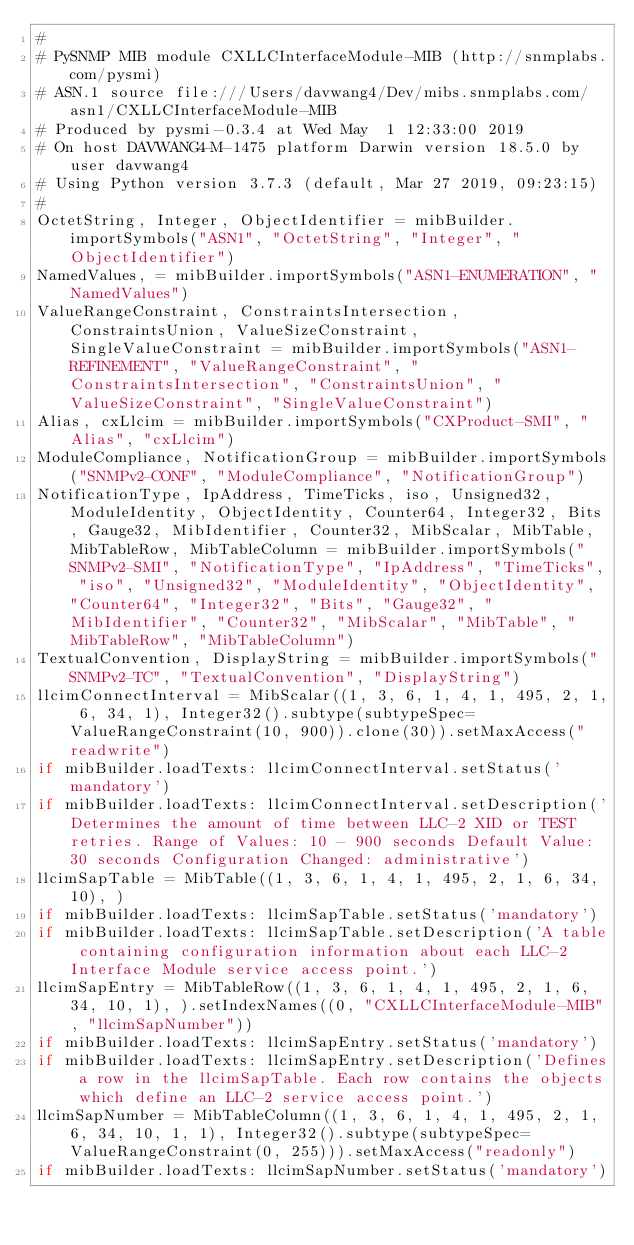Convert code to text. <code><loc_0><loc_0><loc_500><loc_500><_Python_>#
# PySNMP MIB module CXLLCInterfaceModule-MIB (http://snmplabs.com/pysmi)
# ASN.1 source file:///Users/davwang4/Dev/mibs.snmplabs.com/asn1/CXLLCInterfaceModule-MIB
# Produced by pysmi-0.3.4 at Wed May  1 12:33:00 2019
# On host DAVWANG4-M-1475 platform Darwin version 18.5.0 by user davwang4
# Using Python version 3.7.3 (default, Mar 27 2019, 09:23:15) 
#
OctetString, Integer, ObjectIdentifier = mibBuilder.importSymbols("ASN1", "OctetString", "Integer", "ObjectIdentifier")
NamedValues, = mibBuilder.importSymbols("ASN1-ENUMERATION", "NamedValues")
ValueRangeConstraint, ConstraintsIntersection, ConstraintsUnion, ValueSizeConstraint, SingleValueConstraint = mibBuilder.importSymbols("ASN1-REFINEMENT", "ValueRangeConstraint", "ConstraintsIntersection", "ConstraintsUnion", "ValueSizeConstraint", "SingleValueConstraint")
Alias, cxLlcim = mibBuilder.importSymbols("CXProduct-SMI", "Alias", "cxLlcim")
ModuleCompliance, NotificationGroup = mibBuilder.importSymbols("SNMPv2-CONF", "ModuleCompliance", "NotificationGroup")
NotificationType, IpAddress, TimeTicks, iso, Unsigned32, ModuleIdentity, ObjectIdentity, Counter64, Integer32, Bits, Gauge32, MibIdentifier, Counter32, MibScalar, MibTable, MibTableRow, MibTableColumn = mibBuilder.importSymbols("SNMPv2-SMI", "NotificationType", "IpAddress", "TimeTicks", "iso", "Unsigned32", "ModuleIdentity", "ObjectIdentity", "Counter64", "Integer32", "Bits", "Gauge32", "MibIdentifier", "Counter32", "MibScalar", "MibTable", "MibTableRow", "MibTableColumn")
TextualConvention, DisplayString = mibBuilder.importSymbols("SNMPv2-TC", "TextualConvention", "DisplayString")
llcimConnectInterval = MibScalar((1, 3, 6, 1, 4, 1, 495, 2, 1, 6, 34, 1), Integer32().subtype(subtypeSpec=ValueRangeConstraint(10, 900)).clone(30)).setMaxAccess("readwrite")
if mibBuilder.loadTexts: llcimConnectInterval.setStatus('mandatory')
if mibBuilder.loadTexts: llcimConnectInterval.setDescription('Determines the amount of time between LLC-2 XID or TEST retries. Range of Values: 10 - 900 seconds Default Value: 30 seconds Configuration Changed: administrative')
llcimSapTable = MibTable((1, 3, 6, 1, 4, 1, 495, 2, 1, 6, 34, 10), )
if mibBuilder.loadTexts: llcimSapTable.setStatus('mandatory')
if mibBuilder.loadTexts: llcimSapTable.setDescription('A table containing configuration information about each LLC-2 Interface Module service access point.')
llcimSapEntry = MibTableRow((1, 3, 6, 1, 4, 1, 495, 2, 1, 6, 34, 10, 1), ).setIndexNames((0, "CXLLCInterfaceModule-MIB", "llcimSapNumber"))
if mibBuilder.loadTexts: llcimSapEntry.setStatus('mandatory')
if mibBuilder.loadTexts: llcimSapEntry.setDescription('Defines a row in the llcimSapTable. Each row contains the objects which define an LLC-2 service access point.')
llcimSapNumber = MibTableColumn((1, 3, 6, 1, 4, 1, 495, 2, 1, 6, 34, 10, 1, 1), Integer32().subtype(subtypeSpec=ValueRangeConstraint(0, 255))).setMaxAccess("readonly")
if mibBuilder.loadTexts: llcimSapNumber.setStatus('mandatory')</code> 